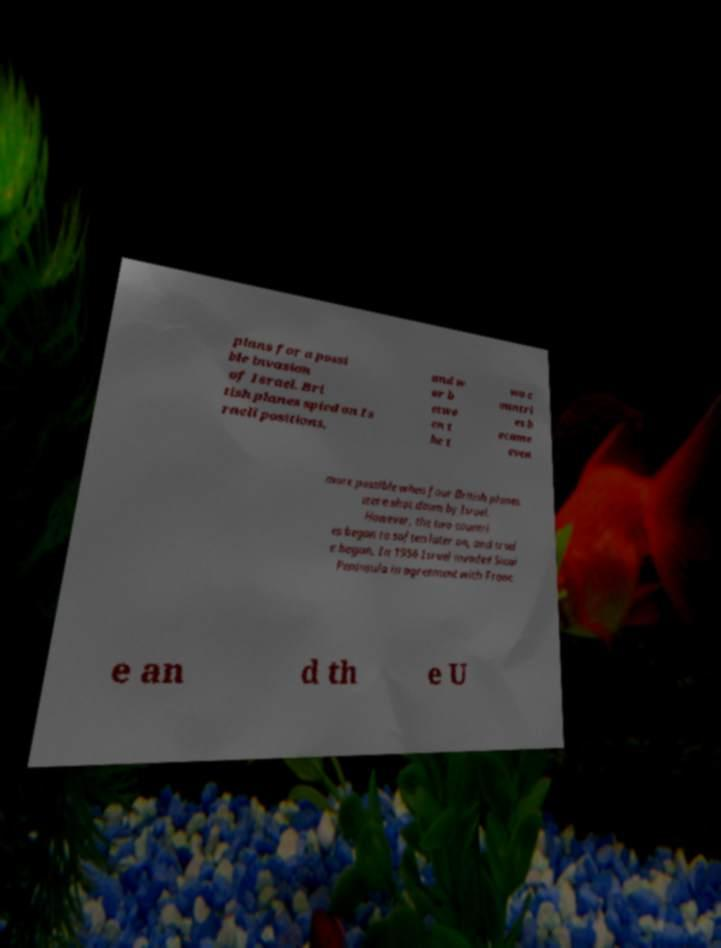I need the written content from this picture converted into text. Can you do that? plans for a possi ble invasion of Israel. Bri tish planes spied on Is raeli positions, and w ar b etwe en t he t wo c ountri es b ecame even more possible when four British planes were shot down by Israel. However, the two countri es began to soften later on, and trad e began. In 1956 Israel invaded Sinai Peninsula in agreement with Franc e an d th e U 